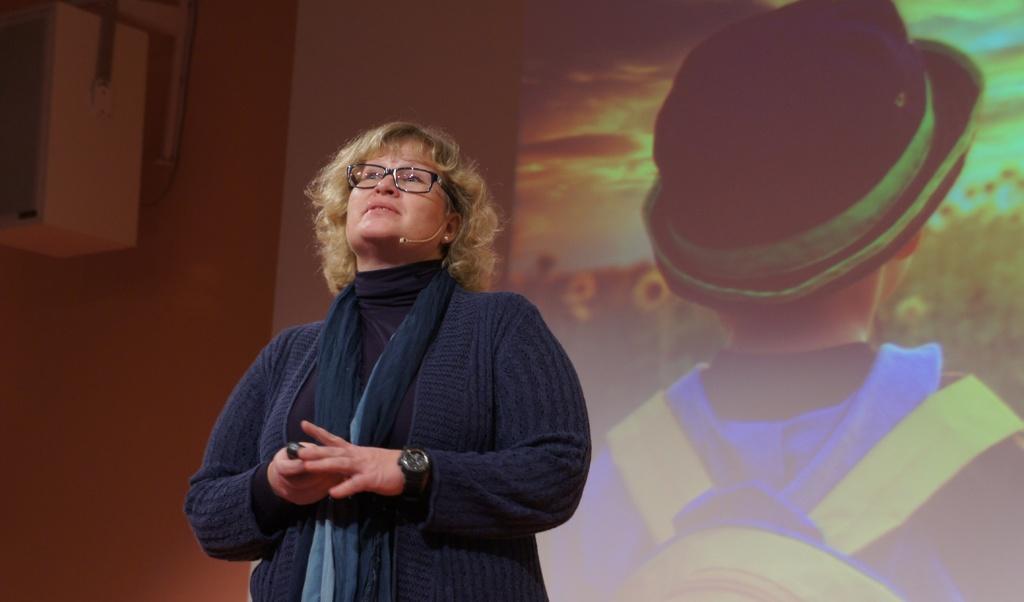Please provide a concise description of this image. In this image, in the middle, we can see a woman wearing a blue color dress is standing and holding an object in her hand. On the right side, we can see a screen, on the screen, we can see a person wearing a backpack. In the background, we can see some plants with flowers, at the top of the screen, we can see a sky which is a bit cloudy. On the left side, we can see of the image black color and white color. 